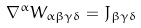Convert formula to latex. <formula><loc_0><loc_0><loc_500><loc_500>\nabla ^ { \alpha } W _ { \alpha \beta \gamma \delta } = J _ { \beta \gamma \delta }</formula> 